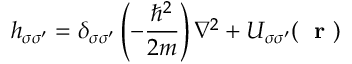Convert formula to latex. <formula><loc_0><loc_0><loc_500><loc_500>h _ { \sigma \sigma ^ { \prime } } = \delta _ { \sigma \sigma ^ { \prime } } \left ( - \frac { \hbar { ^ } { 2 } } { 2 m } \right ) \nabla ^ { 2 } + U _ { \sigma \sigma ^ { \prime } } ( r )</formula> 